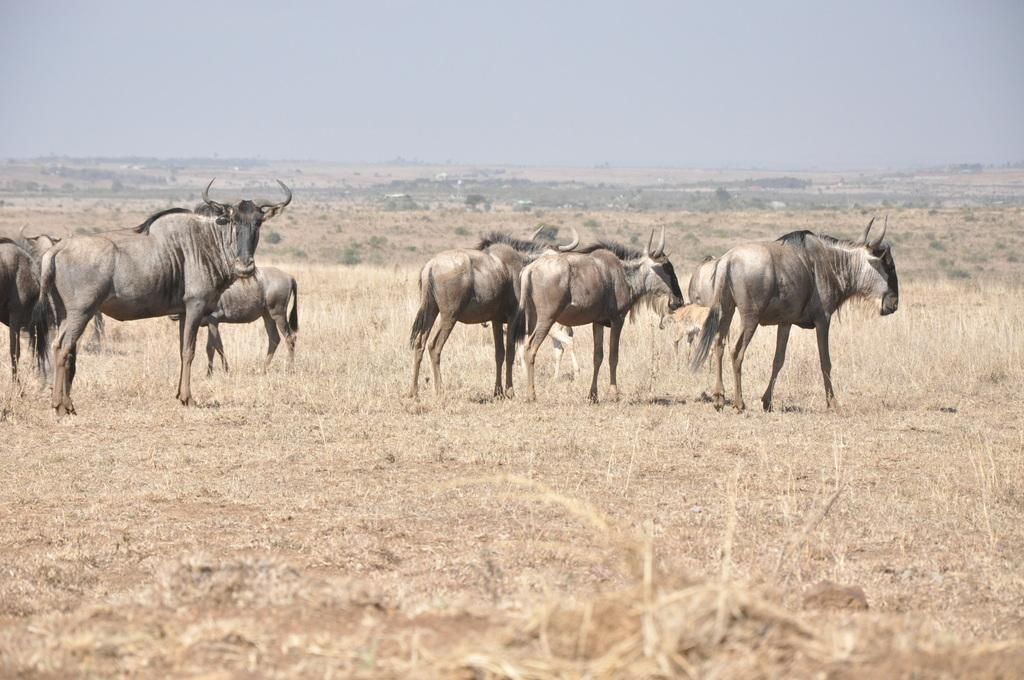What type of animals can be seen on the ground in the image? There are animals on the ground in the image, but the specific type is not mentioned in the facts. What type of vegetation is visible in the image? There is grass visible in the image. What else can be seen in the image besides the animals and grass? There are trees in the image. What is visible in the background of the image? The sky is visible in the image. Can you see any pigs eating berries in the snow in the image? There is no mention of pigs, berries, or snow in the image. The image features animals on the ground, grass, trees, and the sky. 